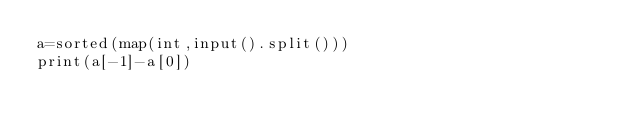<code> <loc_0><loc_0><loc_500><loc_500><_Python_>a=sorted(map(int,input().split()))
print(a[-1]-a[0])</code> 